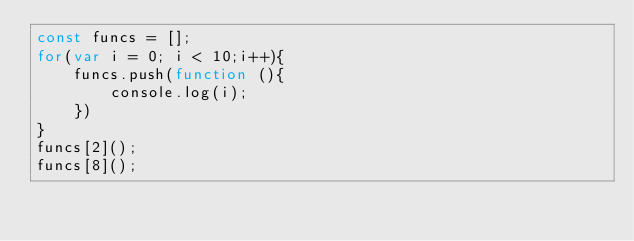<code> <loc_0><loc_0><loc_500><loc_500><_JavaScript_>const funcs = [];
for(var i = 0; i < 10;i++){
    funcs.push(function (){
        console.log(i);
    })
}
funcs[2]();
funcs[8]();</code> 